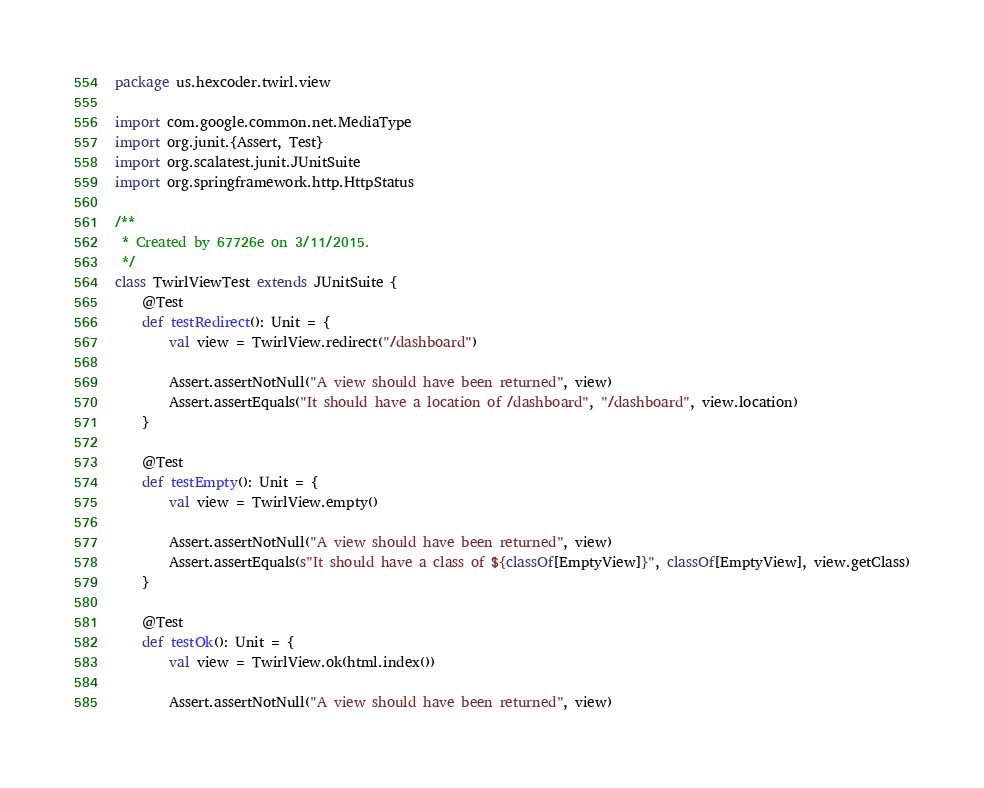Convert code to text. <code><loc_0><loc_0><loc_500><loc_500><_Scala_>package us.hexcoder.twirl.view

import com.google.common.net.MediaType
import org.junit.{Assert, Test}
import org.scalatest.junit.JUnitSuite
import org.springframework.http.HttpStatus

/**
 * Created by 67726e on 3/11/2015.
 */
class TwirlViewTest extends JUnitSuite {
    @Test
    def testRedirect(): Unit = {
        val view = TwirlView.redirect("/dashboard")

        Assert.assertNotNull("A view should have been returned", view)
        Assert.assertEquals("It should have a location of /dashboard", "/dashboard", view.location)
    }

    @Test
    def testEmpty(): Unit = {
        val view = TwirlView.empty()

        Assert.assertNotNull("A view should have been returned", view)
        Assert.assertEquals(s"It should have a class of ${classOf[EmptyView]}", classOf[EmptyView], view.getClass)
    }

    @Test
    def testOk(): Unit = {
        val view = TwirlView.ok(html.index())

        Assert.assertNotNull("A view should have been returned", view)</code> 